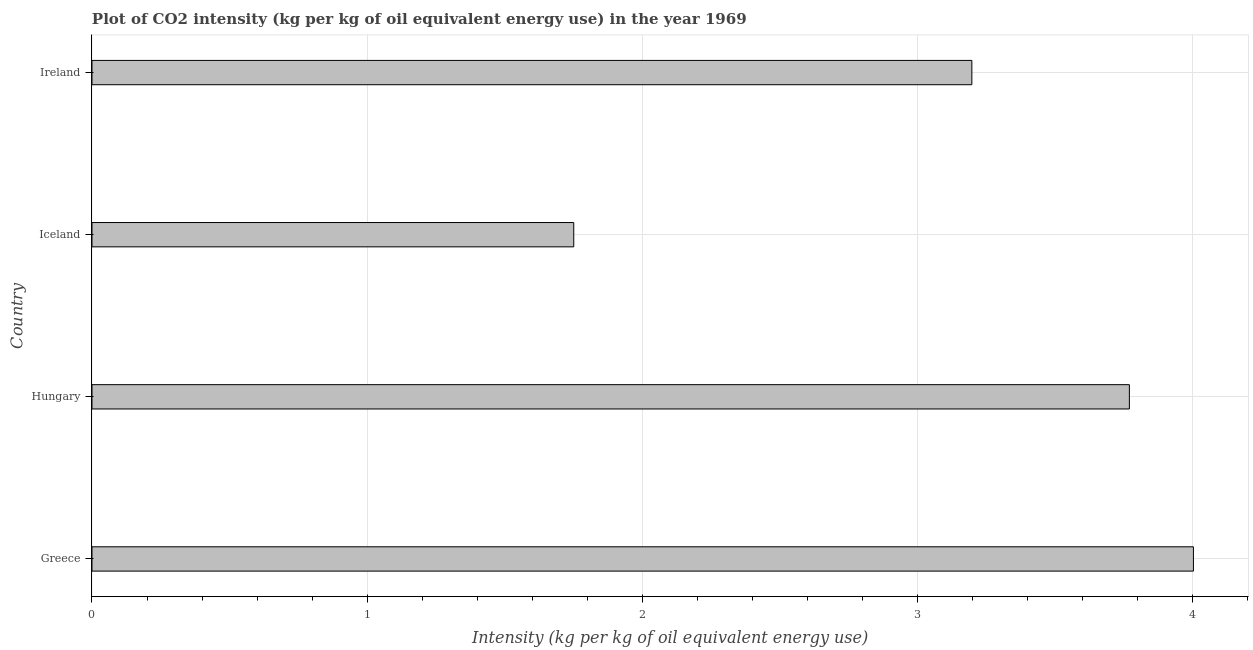Does the graph contain grids?
Offer a terse response. Yes. What is the title of the graph?
Provide a short and direct response. Plot of CO2 intensity (kg per kg of oil equivalent energy use) in the year 1969. What is the label or title of the X-axis?
Your answer should be very brief. Intensity (kg per kg of oil equivalent energy use). What is the label or title of the Y-axis?
Keep it short and to the point. Country. What is the co2 intensity in Ireland?
Provide a succinct answer. 3.2. Across all countries, what is the maximum co2 intensity?
Offer a very short reply. 4. Across all countries, what is the minimum co2 intensity?
Offer a terse response. 1.75. In which country was the co2 intensity maximum?
Make the answer very short. Greece. In which country was the co2 intensity minimum?
Your answer should be compact. Iceland. What is the sum of the co2 intensity?
Make the answer very short. 12.72. What is the difference between the co2 intensity in Iceland and Ireland?
Your answer should be very brief. -1.45. What is the average co2 intensity per country?
Provide a succinct answer. 3.18. What is the median co2 intensity?
Keep it short and to the point. 3.48. In how many countries, is the co2 intensity greater than 2.2 kg?
Make the answer very short. 3. What is the ratio of the co2 intensity in Iceland to that in Ireland?
Provide a succinct answer. 0.55. Is the difference between the co2 intensity in Greece and Ireland greater than the difference between any two countries?
Offer a terse response. No. What is the difference between the highest and the second highest co2 intensity?
Keep it short and to the point. 0.23. Is the sum of the co2 intensity in Greece and Ireland greater than the maximum co2 intensity across all countries?
Provide a short and direct response. Yes. What is the difference between the highest and the lowest co2 intensity?
Keep it short and to the point. 2.25. In how many countries, is the co2 intensity greater than the average co2 intensity taken over all countries?
Ensure brevity in your answer.  3. How many bars are there?
Your answer should be compact. 4. How many countries are there in the graph?
Keep it short and to the point. 4. What is the difference between two consecutive major ticks on the X-axis?
Give a very brief answer. 1. Are the values on the major ticks of X-axis written in scientific E-notation?
Give a very brief answer. No. What is the Intensity (kg per kg of oil equivalent energy use) of Greece?
Provide a succinct answer. 4. What is the Intensity (kg per kg of oil equivalent energy use) in Hungary?
Your answer should be compact. 3.77. What is the Intensity (kg per kg of oil equivalent energy use) of Iceland?
Give a very brief answer. 1.75. What is the Intensity (kg per kg of oil equivalent energy use) in Ireland?
Your answer should be very brief. 3.2. What is the difference between the Intensity (kg per kg of oil equivalent energy use) in Greece and Hungary?
Make the answer very short. 0.23. What is the difference between the Intensity (kg per kg of oil equivalent energy use) in Greece and Iceland?
Ensure brevity in your answer.  2.25. What is the difference between the Intensity (kg per kg of oil equivalent energy use) in Greece and Ireland?
Your response must be concise. 0.81. What is the difference between the Intensity (kg per kg of oil equivalent energy use) in Hungary and Iceland?
Provide a succinct answer. 2.02. What is the difference between the Intensity (kg per kg of oil equivalent energy use) in Hungary and Ireland?
Give a very brief answer. 0.57. What is the difference between the Intensity (kg per kg of oil equivalent energy use) in Iceland and Ireland?
Provide a short and direct response. -1.45. What is the ratio of the Intensity (kg per kg of oil equivalent energy use) in Greece to that in Hungary?
Provide a succinct answer. 1.06. What is the ratio of the Intensity (kg per kg of oil equivalent energy use) in Greece to that in Iceland?
Your answer should be compact. 2.29. What is the ratio of the Intensity (kg per kg of oil equivalent energy use) in Greece to that in Ireland?
Keep it short and to the point. 1.25. What is the ratio of the Intensity (kg per kg of oil equivalent energy use) in Hungary to that in Iceland?
Your answer should be compact. 2.15. What is the ratio of the Intensity (kg per kg of oil equivalent energy use) in Hungary to that in Ireland?
Your answer should be very brief. 1.18. What is the ratio of the Intensity (kg per kg of oil equivalent energy use) in Iceland to that in Ireland?
Offer a very short reply. 0.55. 